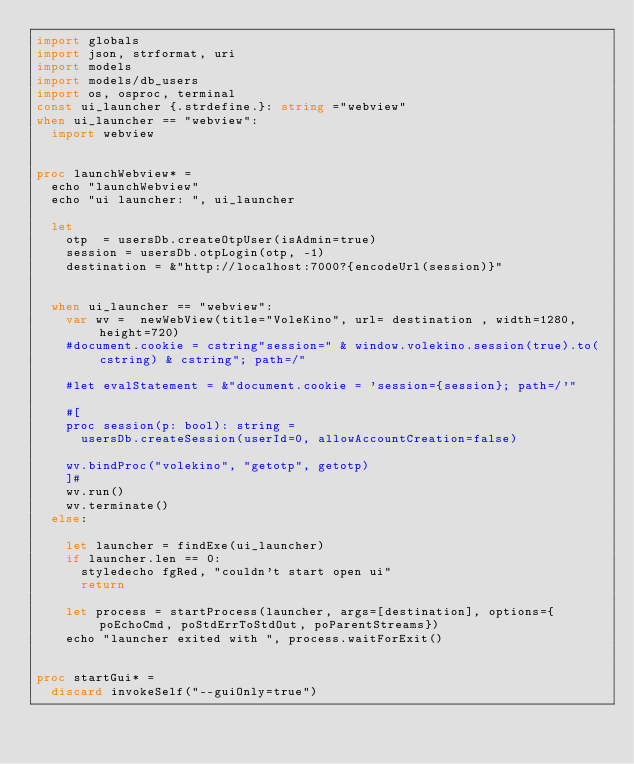Convert code to text. <code><loc_0><loc_0><loc_500><loc_500><_Nim_>import globals
import json, strformat, uri
import models
import models/db_users
import os, osproc, terminal
const ui_launcher {.strdefine.}: string ="webview"
when ui_launcher == "webview":
  import webview


proc launchWebview* =
  echo "launchWebview"
  echo "ui launcher: ", ui_launcher

  let
    otp  = usersDb.createOtpUser(isAdmin=true)
    session = usersDb.otpLogin(otp, -1)
    destination = &"http://localhost:7000?{encodeUrl(session)}"

  
  when ui_launcher == "webview":
    var wv =  newWebView(title="VoleKino", url= destination , width=1280, height=720)
    #document.cookie = cstring"session=" & window.volekino.session(true).to(cstring) & cstring"; path=/"

    #let evalStatement = &"document.cookie = 'session={session}; path=/'"
    
    #[
    proc session(p: bool): string =
      usersDb.createSession(userId=0, allowAccountCreation=false)

    wv.bindProc("volekino", "getotp", getotp)
    ]#
    wv.run()
    wv.terminate()
  else:

    let launcher = findExe(ui_launcher)
    if launcher.len == 0:
      styledecho fgRed, "couldn't start open ui"
      return

    let process = startProcess(launcher, args=[destination], options={poEchoCmd, poStdErrToStdOut, poParentStreams})
    echo "launcher exited with ", process.waitForExit()


proc startGui* =
  discard invokeSelf("--guiOnly=true")
</code> 